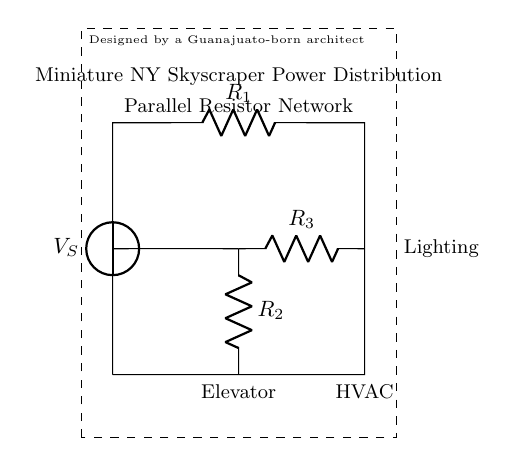What is the source voltage in this circuit? The source voltage is represented as \( V_S \) in the diagram. Since there’s no numeric value provided in the visual, we only identify it by name.
Answer: V_S How many resistors are present in the circuit? There are a total of three resistors identified as \( R_1 \), \( R_2 \), and \( R_3 \) in the diagram. Each is visually distinct.
Answer: 3 What electrical components are connected to this circuit? The circuit consists of an elevator, HVAC, and lighting. These are labeled alongside their respective connections in the diagram.
Answer: Elevator, HVAC, Lighting Which resistor has a parallel connection with \( R_1 \)? The resistor \( R_2 \) and \( R_3 \) are in parallel with respect to \( R_1 \) from the circuit layout, connecting from the same voltage source.
Answer: R_2 and R_3 How is the total current distributed in this circuit? The current splits among \( R_2 \) and \( R_3 \) due to their parallel configuration while the current through \( R_1 \) remains the same as the total current coming from the voltage source. This is the basic function of a current divider.
Answer: Divided among R_2 and R_3 What type of circuit configuration is used in this diagram? The diagram primarily depicts a parallel resistor network, which is a specific type of current divider circuit allowing for distributed power across multiple branches.
Answer: Parallel resistor network 